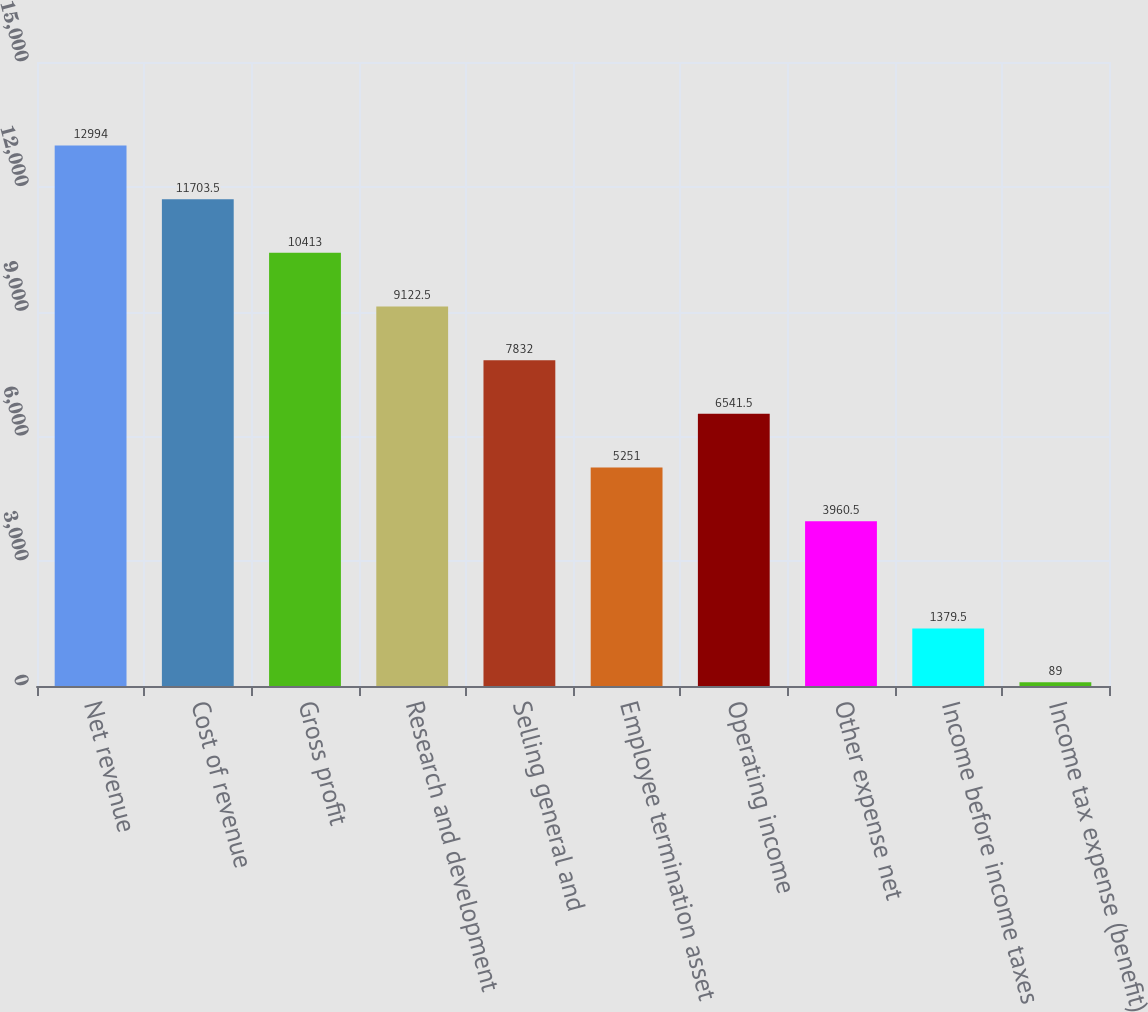<chart> <loc_0><loc_0><loc_500><loc_500><bar_chart><fcel>Net revenue<fcel>Cost of revenue<fcel>Gross profit<fcel>Research and development<fcel>Selling general and<fcel>Employee termination asset<fcel>Operating income<fcel>Other expense net<fcel>Income before income taxes<fcel>Income tax expense (benefit)<nl><fcel>12994<fcel>11703.5<fcel>10413<fcel>9122.5<fcel>7832<fcel>5251<fcel>6541.5<fcel>3960.5<fcel>1379.5<fcel>89<nl></chart> 